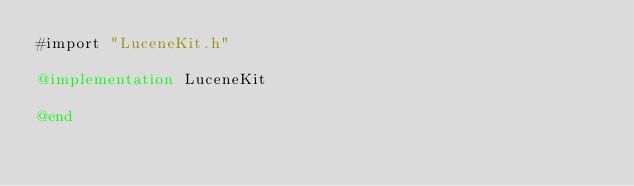Convert code to text. <code><loc_0><loc_0><loc_500><loc_500><_ObjectiveC_>#import "LuceneKit.h"

@implementation LuceneKit

@end
</code> 